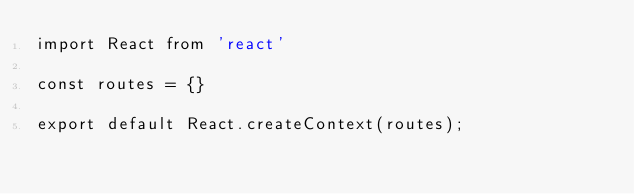Convert code to text. <code><loc_0><loc_0><loc_500><loc_500><_JavaScript_>import React from 'react'

const routes = {}

export default React.createContext(routes);
</code> 